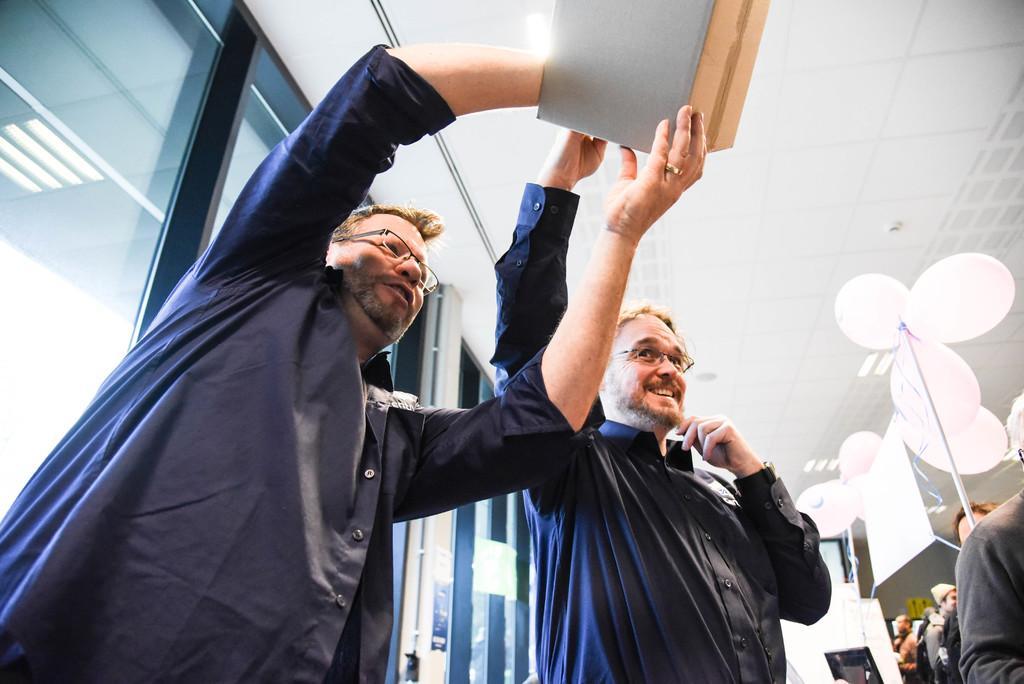In one or two sentences, can you explain what this image depicts? In this picture I can see two persons standing and holding an object, there are lights, balloons, there are group of people and there are glass doors. 